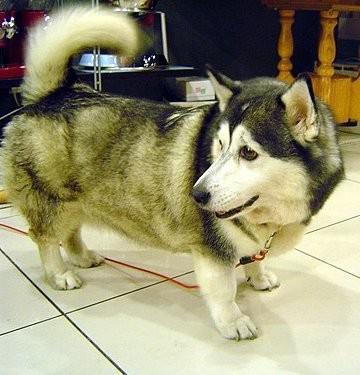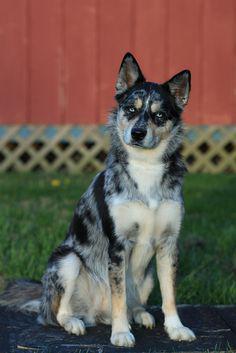The first image is the image on the left, the second image is the image on the right. For the images shown, is this caption "In one of the images, a Malamute is near a man who is sitting on a couch." true? Answer yes or no. No. The first image is the image on the left, the second image is the image on the right. Evaluate the accuracy of this statement regarding the images: "One image shows a single dog standing in profile, and the other image shows a man sitting on an overstuffed couch near a big dog.". Is it true? Answer yes or no. No. 